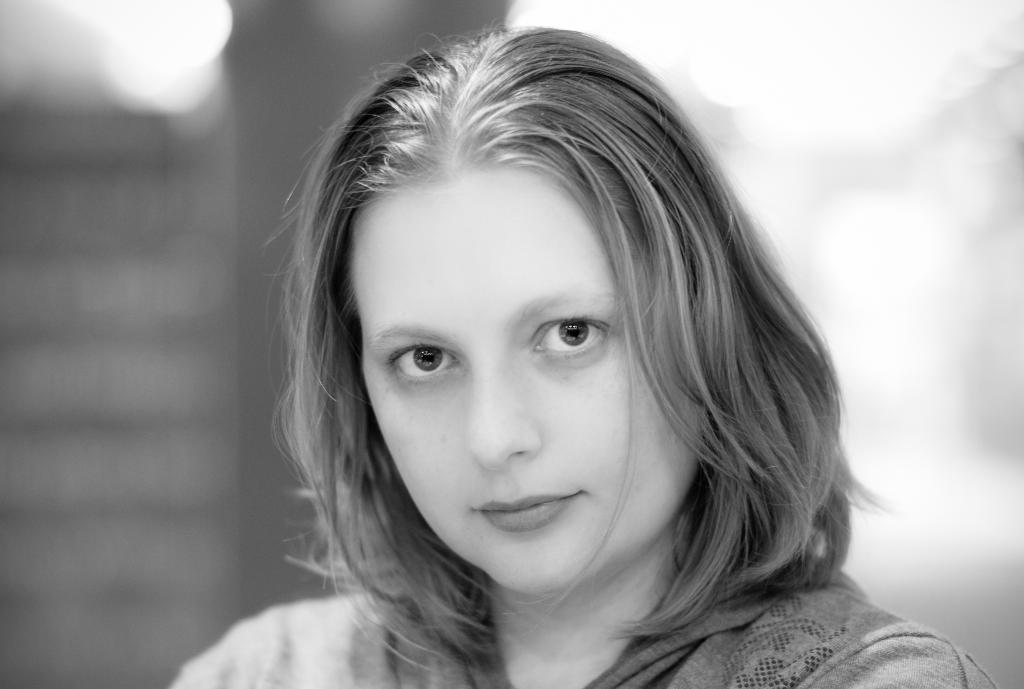Who is the main subject in the image? There is a woman in the center of the image. What can be seen in the background of the image? There is a wall visible in the background of the image. What type of vase is placed on the ground in the image? There is no vase present in the image; it only features a woman and a wall in the background. 